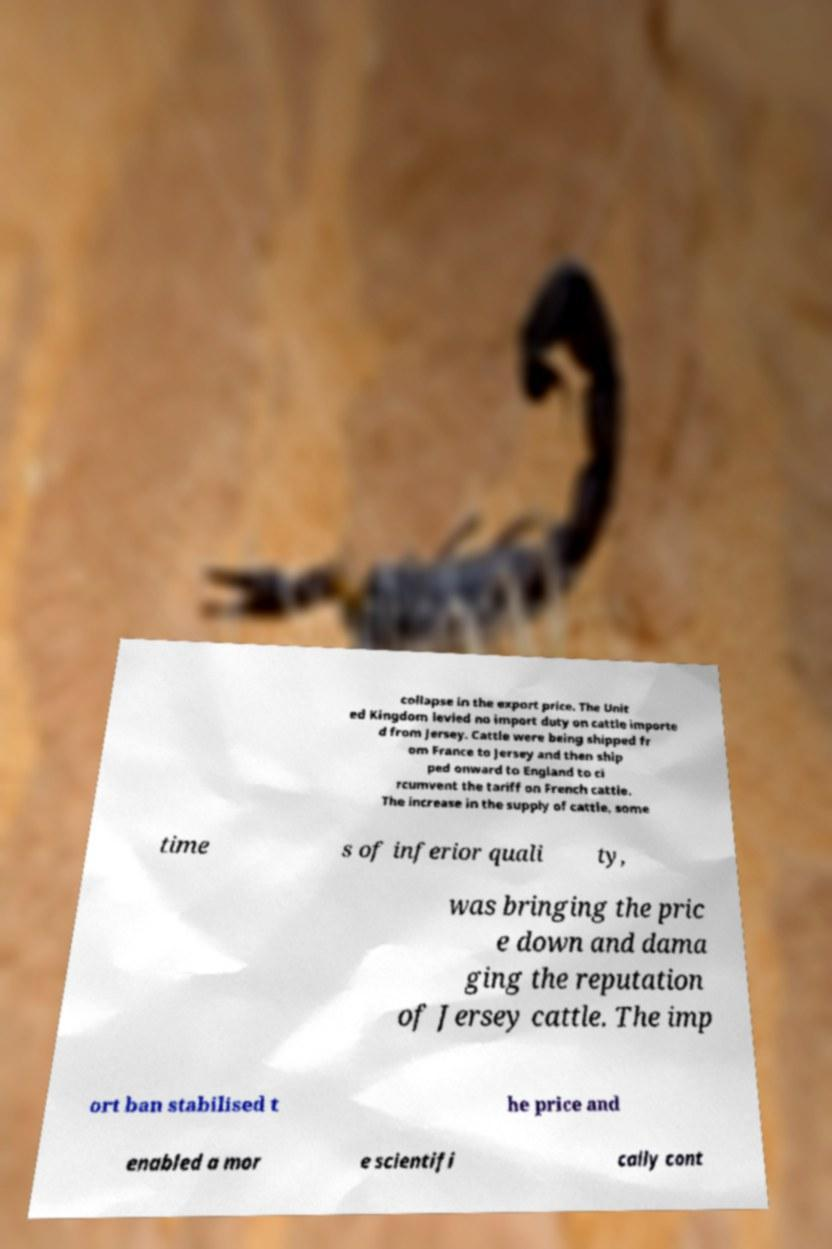Could you extract and type out the text from this image? collapse in the export price. The Unit ed Kingdom levied no import duty on cattle importe d from Jersey. Cattle were being shipped fr om France to Jersey and then ship ped onward to England to ci rcumvent the tariff on French cattle. The increase in the supply of cattle, some time s of inferior quali ty, was bringing the pric e down and dama ging the reputation of Jersey cattle. The imp ort ban stabilised t he price and enabled a mor e scientifi cally cont 